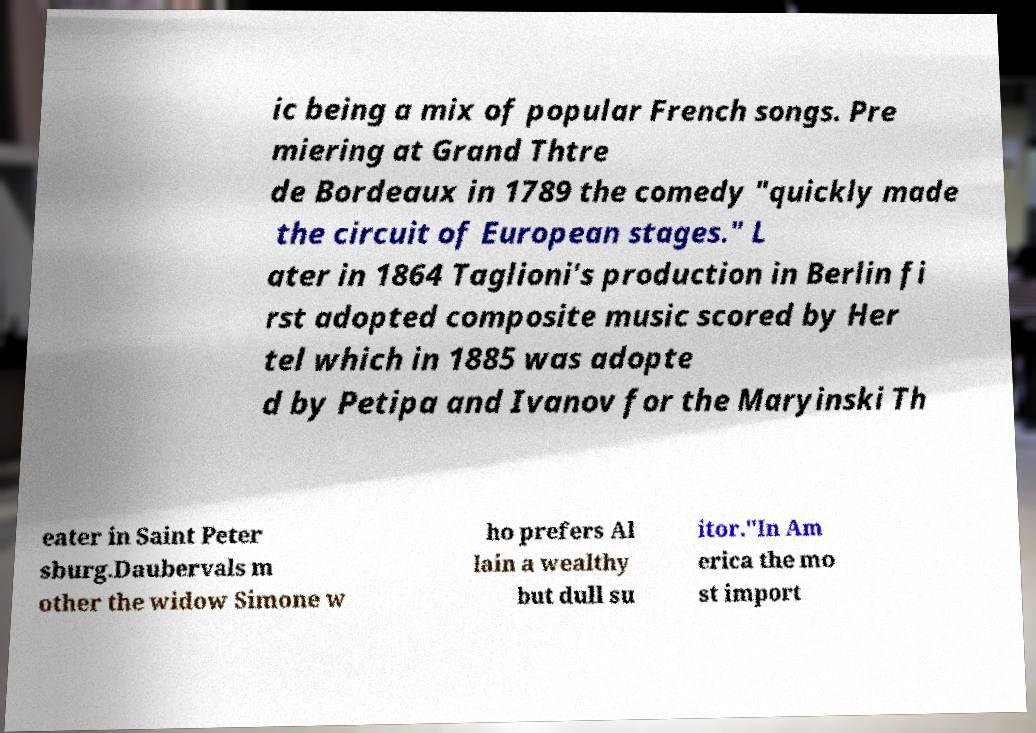What messages or text are displayed in this image? I need them in a readable, typed format. ic being a mix of popular French songs. Pre miering at Grand Thtre de Bordeaux in 1789 the comedy "quickly made the circuit of European stages." L ater in 1864 Taglioni's production in Berlin fi rst adopted composite music scored by Her tel which in 1885 was adopte d by Petipa and Ivanov for the Maryinski Th eater in Saint Peter sburg.Daubervals m other the widow Simone w ho prefers Al lain a wealthy but dull su itor."In Am erica the mo st import 